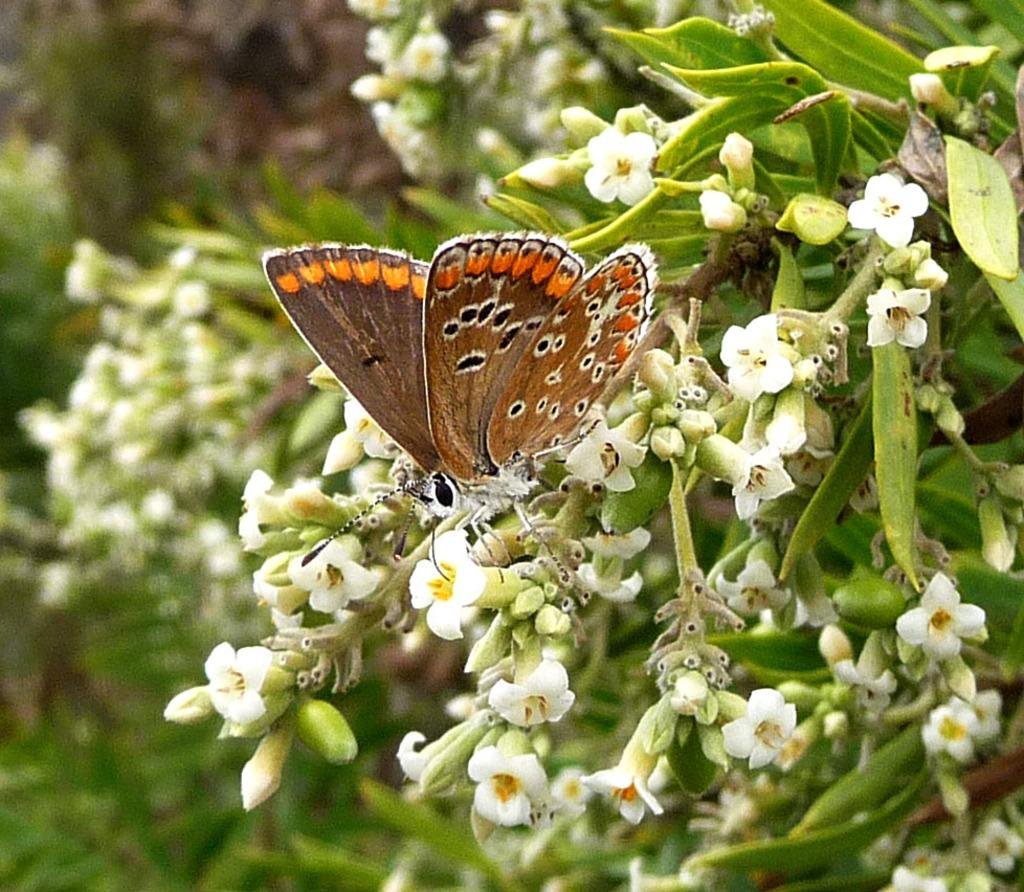What types of living organisms can be seen in the image? The image contains plants and flowers. What other creature can be seen in the image? There is a butterfly in the image. Can you describe the quality of the image on the left side? The left side of the image is blurred. What type of journey is the butterfly taking in the image? There is no indication of a journey in the image; the butterfly is simply present among the plants and flowers. 